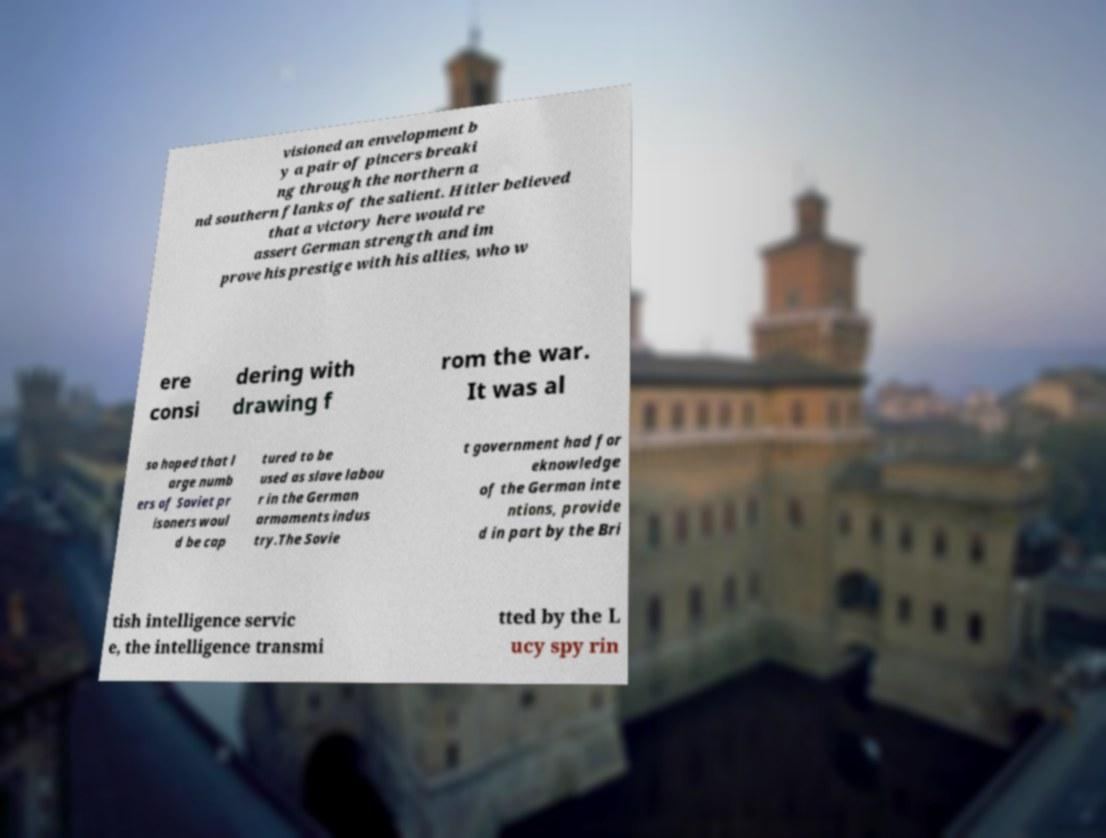There's text embedded in this image that I need extracted. Can you transcribe it verbatim? visioned an envelopment b y a pair of pincers breaki ng through the northern a nd southern flanks of the salient. Hitler believed that a victory here would re assert German strength and im prove his prestige with his allies, who w ere consi dering with drawing f rom the war. It was al so hoped that l arge numb ers of Soviet pr isoners woul d be cap tured to be used as slave labou r in the German armaments indus try.The Sovie t government had for eknowledge of the German inte ntions, provide d in part by the Bri tish intelligence servic e, the intelligence transmi tted by the L ucy spy rin 